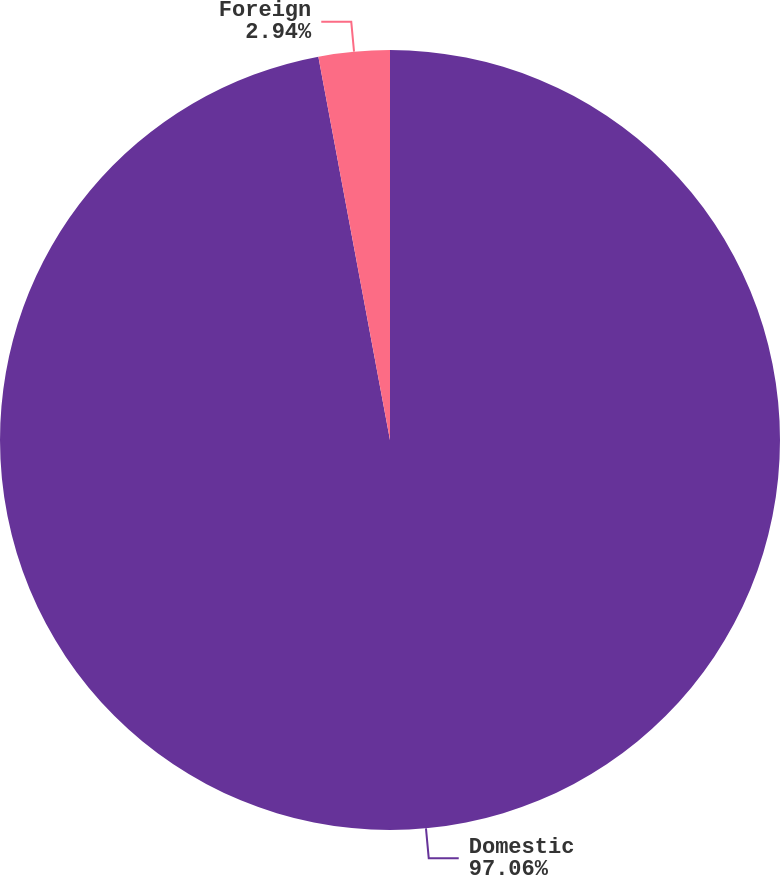Convert chart to OTSL. <chart><loc_0><loc_0><loc_500><loc_500><pie_chart><fcel>Domestic<fcel>Foreign<nl><fcel>97.06%<fcel>2.94%<nl></chart> 